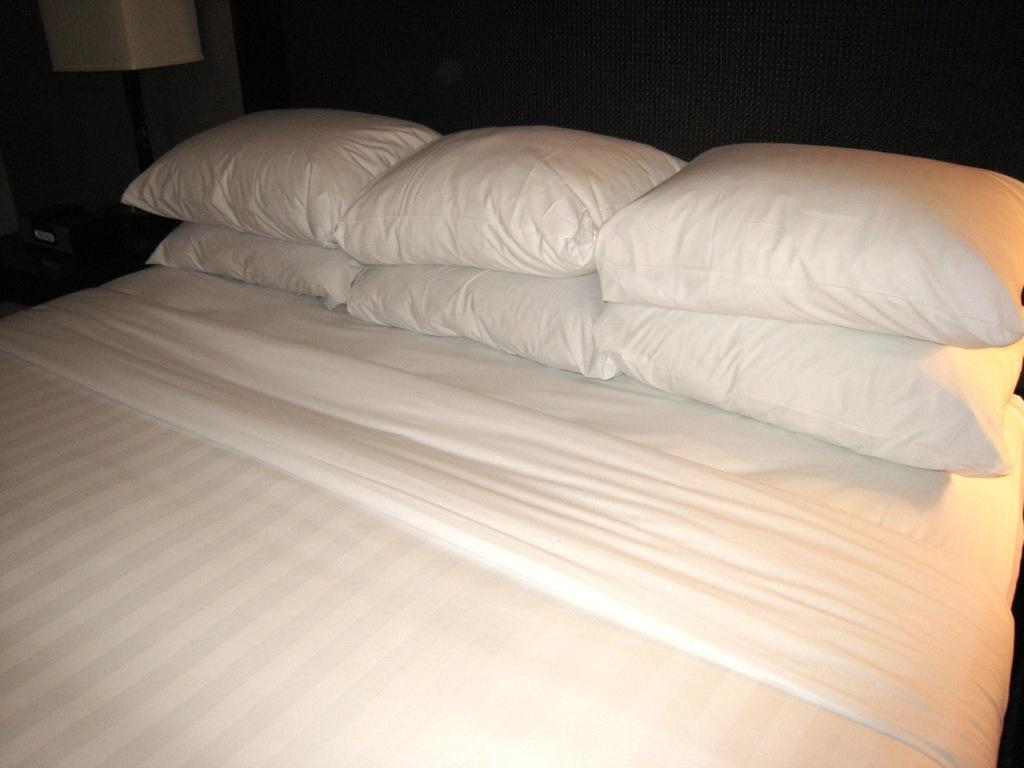What type of furniture is present in the image? There is a bed in the image. What is placed on the bed? There are pillows on the bed. Can you describe an object in the top left corner of the image? There is a lamp at the top left of the image. What type of car is parked in front of the bed in the image? There is no car present in the image; it only features a bed, pillows, and a lamp. 